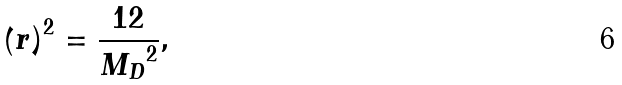Convert formula to latex. <formula><loc_0><loc_0><loc_500><loc_500>\left ( r \right ) ^ { 2 } = \frac { 1 2 } { { M _ { D } } ^ { 2 } } ,</formula> 